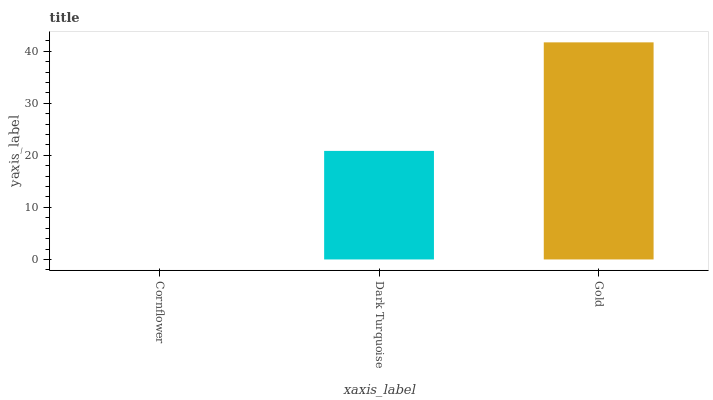Is Cornflower the minimum?
Answer yes or no. Yes. Is Gold the maximum?
Answer yes or no. Yes. Is Dark Turquoise the minimum?
Answer yes or no. No. Is Dark Turquoise the maximum?
Answer yes or no. No. Is Dark Turquoise greater than Cornflower?
Answer yes or no. Yes. Is Cornflower less than Dark Turquoise?
Answer yes or no. Yes. Is Cornflower greater than Dark Turquoise?
Answer yes or no. No. Is Dark Turquoise less than Cornflower?
Answer yes or no. No. Is Dark Turquoise the high median?
Answer yes or no. Yes. Is Dark Turquoise the low median?
Answer yes or no. Yes. Is Cornflower the high median?
Answer yes or no. No. Is Cornflower the low median?
Answer yes or no. No. 